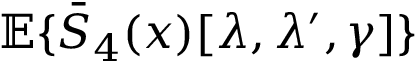<formula> <loc_0><loc_0><loc_500><loc_500>{ \mathbb { E } } \{ \bar { S } _ { 4 } ( x ) [ \lambda , \lambda ^ { \prime } , \gamma ] \}</formula> 